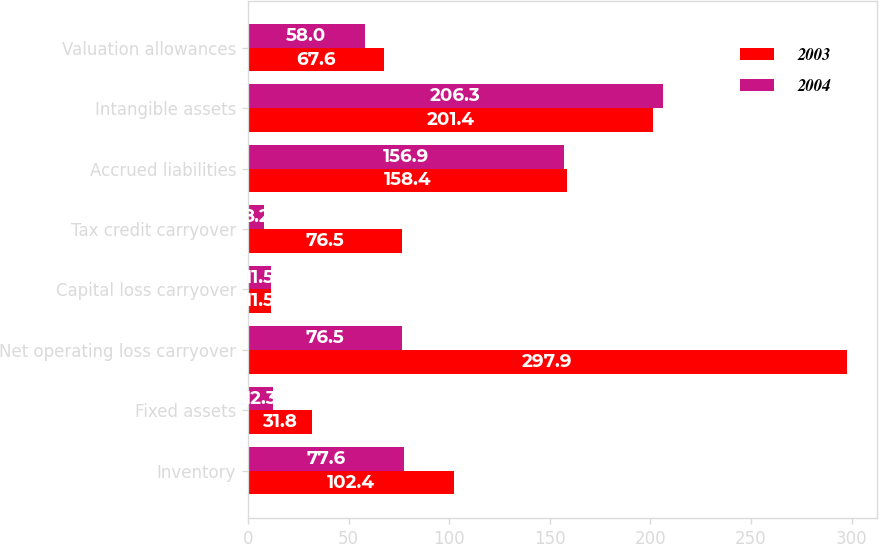Convert chart to OTSL. <chart><loc_0><loc_0><loc_500><loc_500><stacked_bar_chart><ecel><fcel>Inventory<fcel>Fixed assets<fcel>Net operating loss carryover<fcel>Capital loss carryover<fcel>Tax credit carryover<fcel>Accrued liabilities<fcel>Intangible assets<fcel>Valuation allowances<nl><fcel>2003<fcel>102.4<fcel>31.8<fcel>297.9<fcel>11.5<fcel>76.5<fcel>158.4<fcel>201.4<fcel>67.6<nl><fcel>2004<fcel>77.6<fcel>12.3<fcel>76.5<fcel>11.5<fcel>8.2<fcel>156.9<fcel>206.3<fcel>58<nl></chart> 